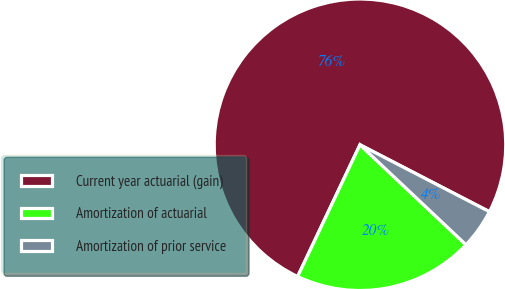Convert chart to OTSL. <chart><loc_0><loc_0><loc_500><loc_500><pie_chart><fcel>Current year actuarial (gain)<fcel>Amortization of actuarial<fcel>Amortization of prior service<nl><fcel>75.56%<fcel>20.0%<fcel>4.44%<nl></chart> 